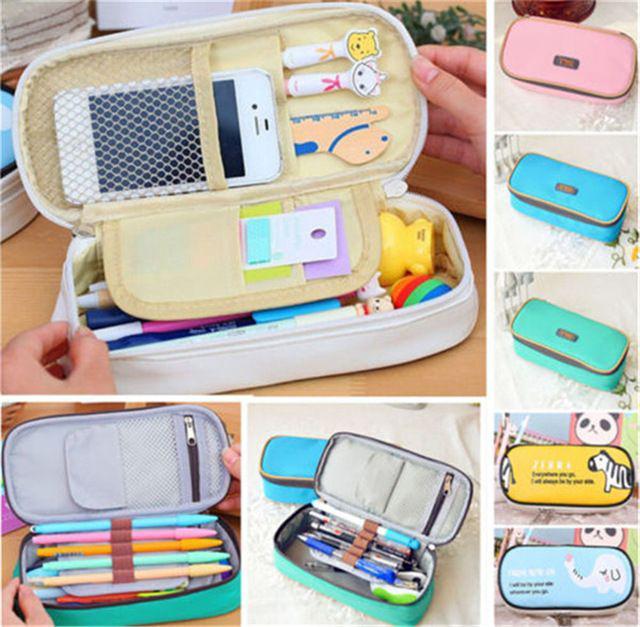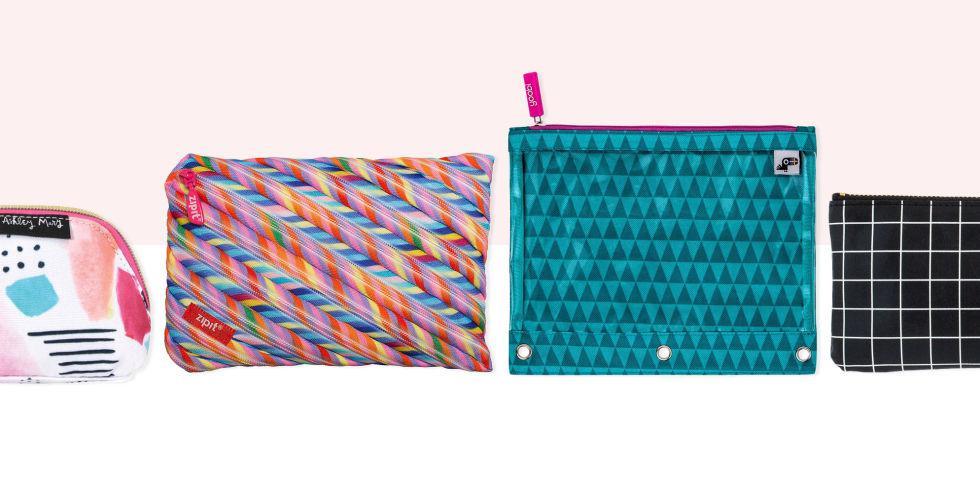The first image is the image on the left, the second image is the image on the right. For the images displayed, is the sentence "At least of the images shows only one pencil pouch." factually correct? Answer yes or no. No. The first image is the image on the left, the second image is the image on the right. Analyze the images presented: Is the assertion "An image collage shows a pencil case that opens clam-shell style, along with the same type case closed." valid? Answer yes or no. Yes. 